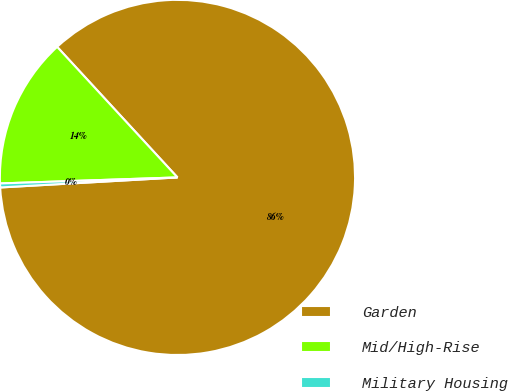Convert chart. <chart><loc_0><loc_0><loc_500><loc_500><pie_chart><fcel>Garden<fcel>Mid/High-Rise<fcel>Military Housing<nl><fcel>85.95%<fcel>13.69%<fcel>0.36%<nl></chart> 